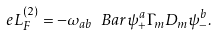<formula> <loc_0><loc_0><loc_500><loc_500>\ e L _ { F } ^ { ( 2 ) } = - \omega _ { a b } \ B a r \psi ^ { a } _ { + } \Gamma _ { m } D _ { m } \psi ^ { b } _ { - } .</formula> 